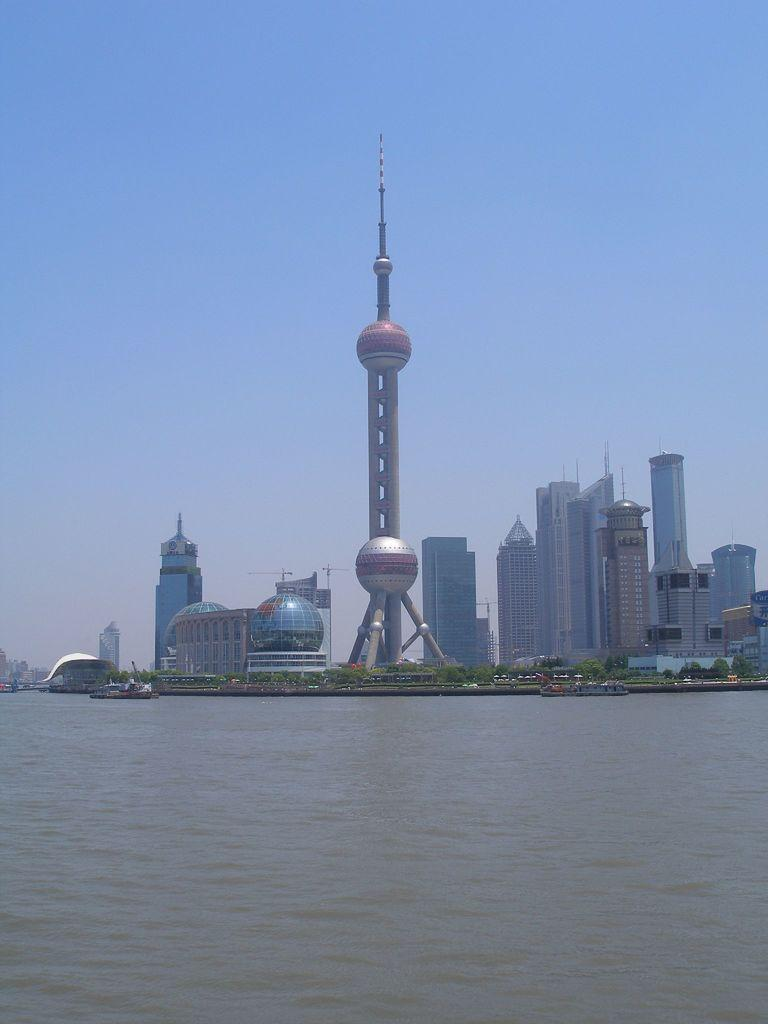What type of structures can be seen in the image? There are many buildings in the image. What other natural elements are present in the image? There are trees in the image. Are there any tall structures in the image? Yes, there are towers in the image. What is happening on the water in the image? There are boats sailing on the water in the image. What is visible in the background of the image? The sky is visible in the background of the image and appears clear. What type of popcorn is being served in the image? There is no popcorn present in the image. What color is the sweater worn by the head in the image? There is no head or sweater present in the image. 